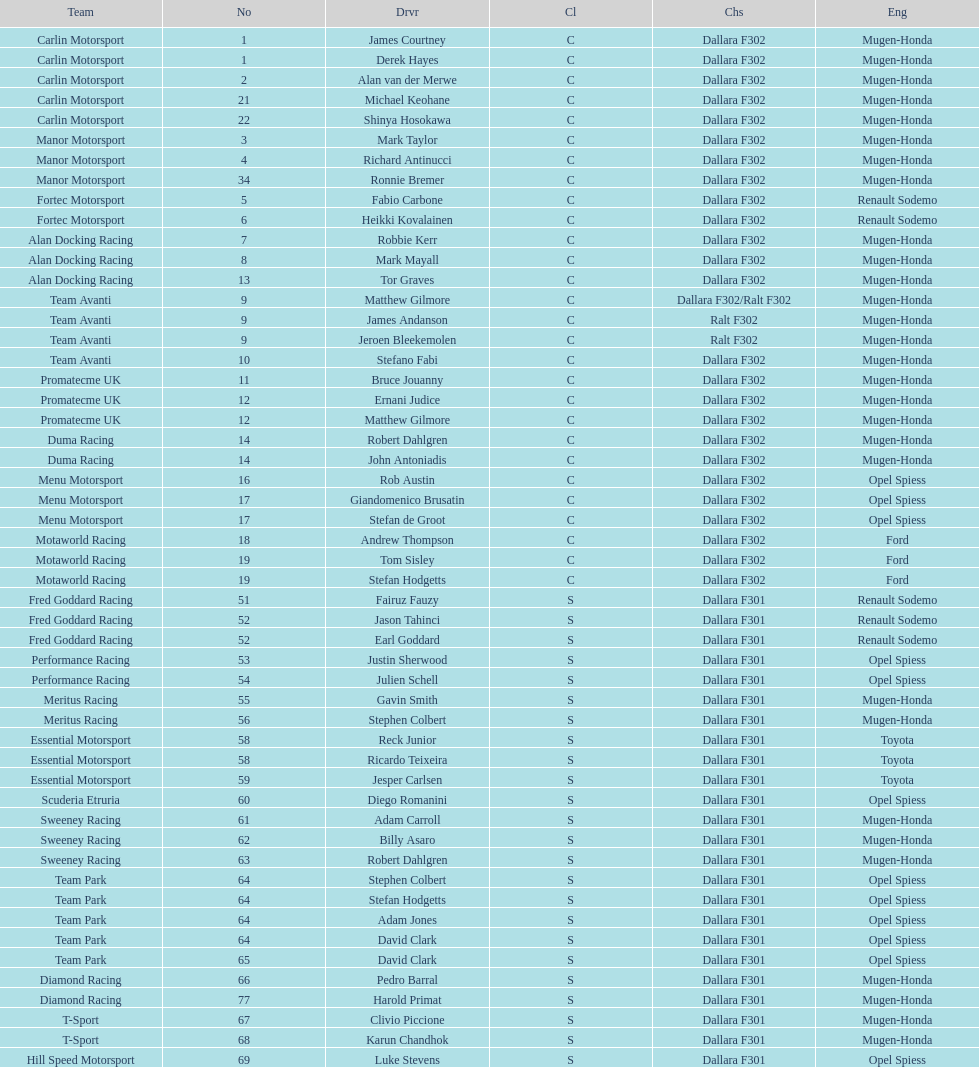The two drivers on t-sport are clivio piccione and what other driver? Karun Chandhok. 